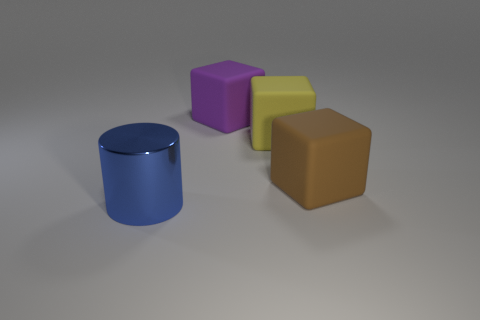How many brown matte blocks are in front of the large brown rubber block?
Your answer should be compact. 0. How many things are purple objects or matte cubes that are behind the large yellow matte block?
Give a very brief answer. 1. There is a large thing that is left of the purple matte object; are there any shiny objects on the left side of it?
Give a very brief answer. No. What color is the block that is on the right side of the yellow matte block?
Give a very brief answer. Brown. Is the number of large cylinders that are in front of the yellow thing the same as the number of big rubber cubes?
Your answer should be compact. No. There is a object that is in front of the yellow thing and behind the large metallic cylinder; what is its shape?
Provide a short and direct response. Cube. Are there any other things that have the same color as the big cylinder?
Offer a very short reply. No. There is a thing in front of the brown rubber object; does it have the same size as the cube that is to the left of the yellow thing?
Keep it short and to the point. Yes. What number of purple cubes have the same material as the large blue thing?
Provide a short and direct response. 0. There is a object that is on the left side of the large cube behind the big yellow thing; how many large things are behind it?
Keep it short and to the point. 3. 